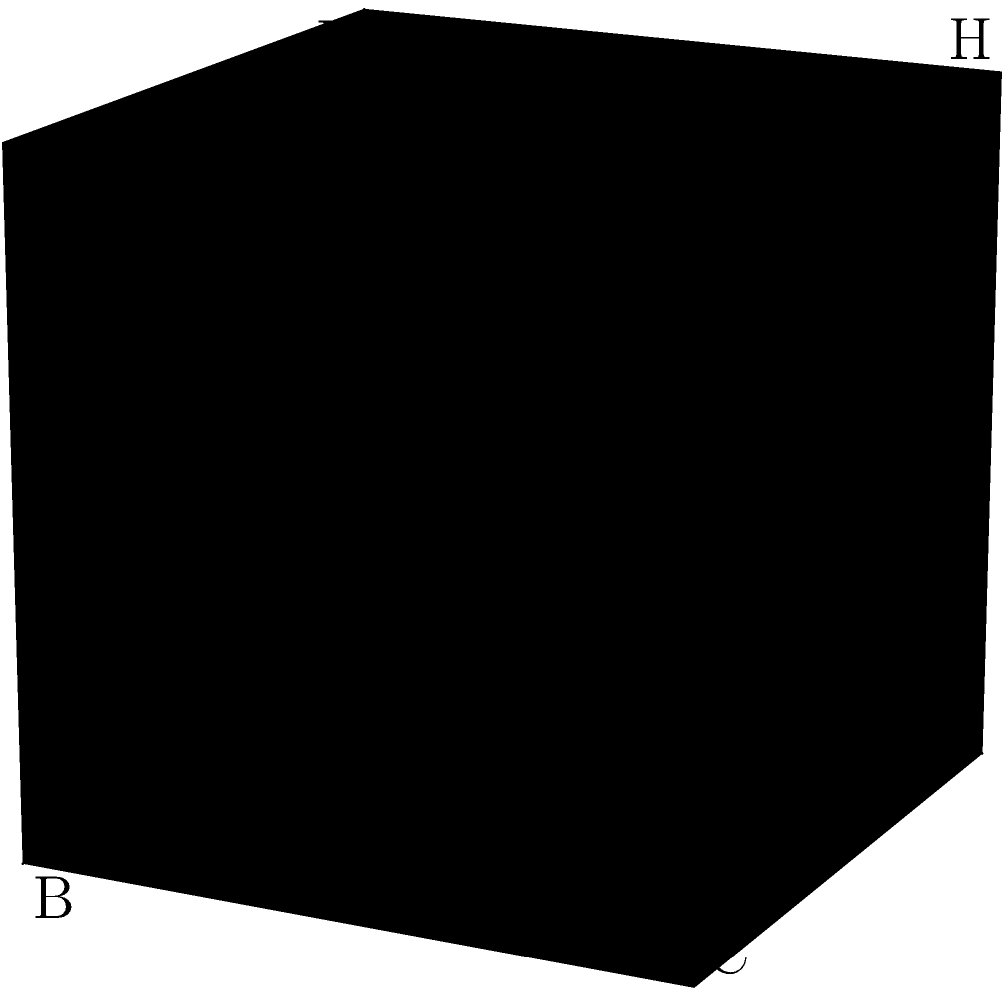In a unit cube ABCDEFGH, consider the planes ABG and ADG. Calculate the angle between these two intersecting planes. To find the angle between two intersecting planes, we need to follow these steps:

1) First, we need to find the normal vectors of both planes:
   - For plane ABG: $\vec{n_1} = \vec{AB} \times \vec{AG} = (1,0,0) \times (1,1,1) = (0,-1,1)$
   - For plane ADG: $\vec{n_2} = \vec{AD} \times \vec{AG} = (0,1,0) \times (1,1,1) = (1,0,-1)$

2) The angle between the planes is the same as the angle between their normal vectors. We can find this using the dot product formula:

   $$\cos \theta = \frac{\vec{n_1} \cdot \vec{n_2}}{|\vec{n_1}||\vec{n_2}|}$$

3) Calculate the dot product:
   $\vec{n_1} \cdot \vec{n_2} = (0)(-1) + (-1)(0) + (1)(-1) = -1$

4) Calculate the magnitudes:
   $|\vec{n_1}| = \sqrt{0^2 + (-1)^2 + 1^2} = \sqrt{2}$
   $|\vec{n_2}| = \sqrt{1^2 + 0^2 + (-1)^2} = \sqrt{2}$

5) Substitute into the formula:
   $$\cos \theta = \frac{-1}{\sqrt{2}\sqrt{2}} = -\frac{1}{2}$$

6) Take the inverse cosine (arccos) of both sides:
   $$\theta = \arccos(-\frac{1}{2})$$

7) This evaluates to approximately 2.0944 radians or 120 degrees.
Answer: 120° 